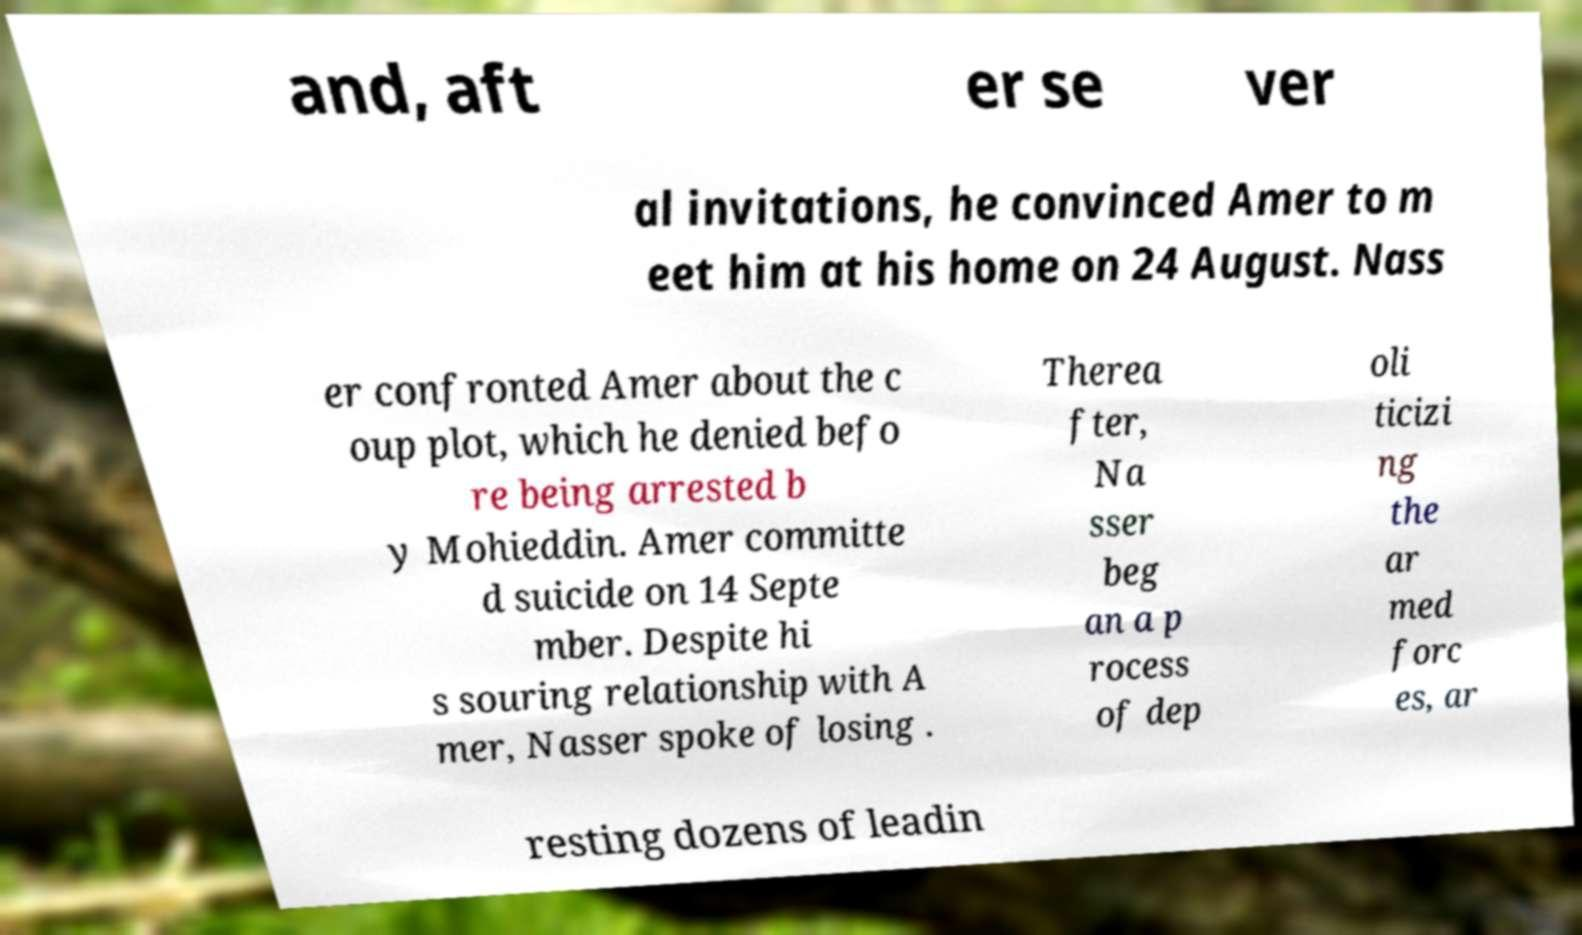Please read and relay the text visible in this image. What does it say? and, aft er se ver al invitations, he convinced Amer to m eet him at his home on 24 August. Nass er confronted Amer about the c oup plot, which he denied befo re being arrested b y Mohieddin. Amer committe d suicide on 14 Septe mber. Despite hi s souring relationship with A mer, Nasser spoke of losing . Therea fter, Na sser beg an a p rocess of dep oli ticizi ng the ar med forc es, ar resting dozens of leadin 